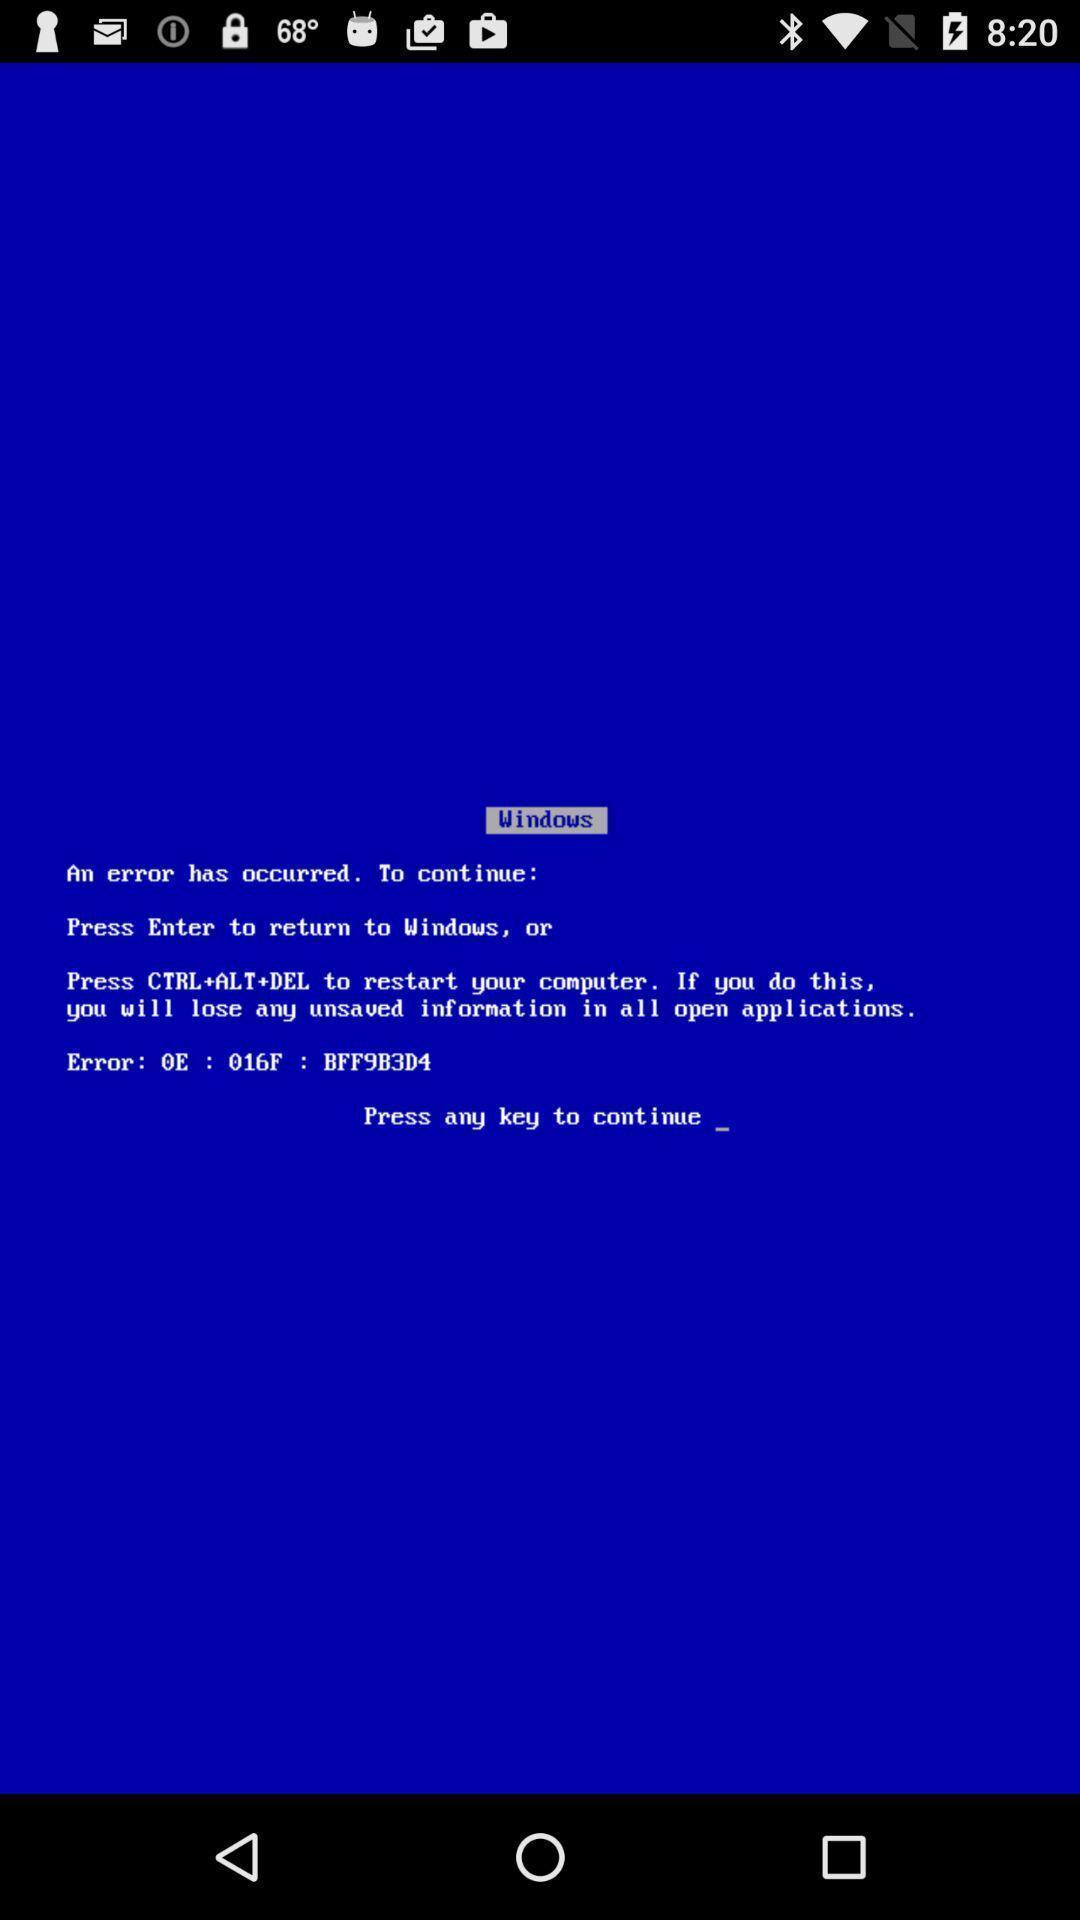Describe this image in words. Welcome page of a travel app. 